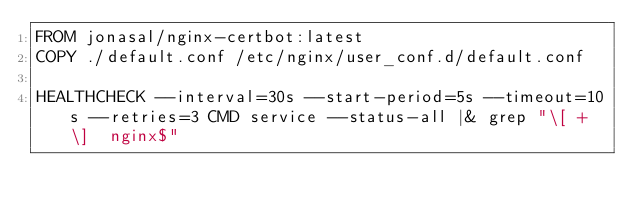Convert code to text. <code><loc_0><loc_0><loc_500><loc_500><_Dockerfile_>FROM jonasal/nginx-certbot:latest
COPY ./default.conf /etc/nginx/user_conf.d/default.conf

HEALTHCHECK --interval=30s --start-period=5s --timeout=10s --retries=3 CMD service --status-all |& grep "\[ + \]  nginx$"</code> 